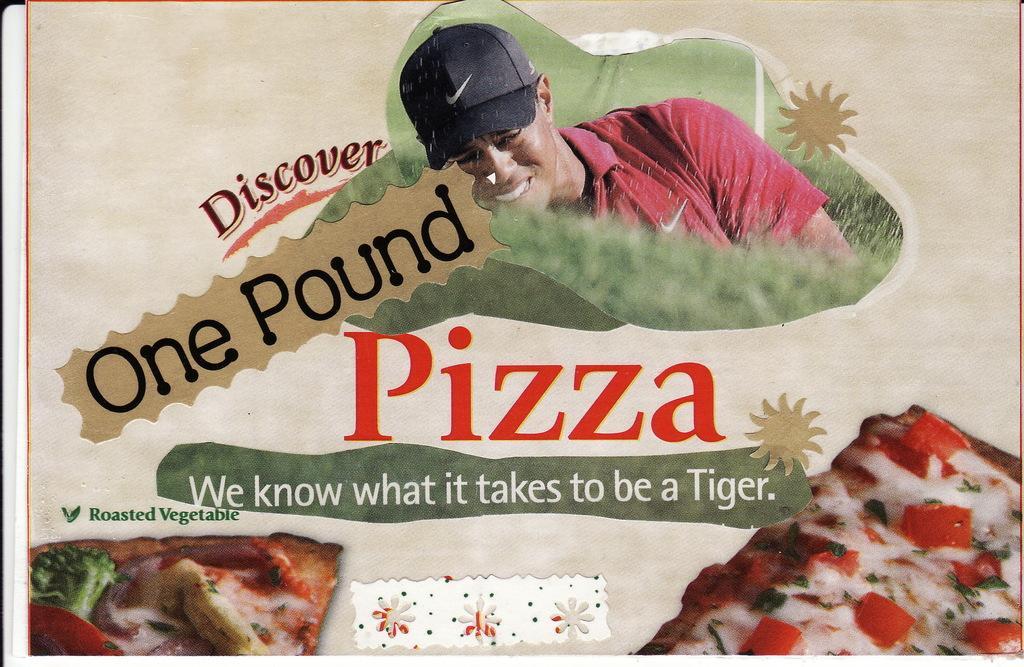Could you give a brief overview of what you see in this image? There is a picture of a person and a pizza on a poster as we can see in the middle of this image and there is a text on it. 